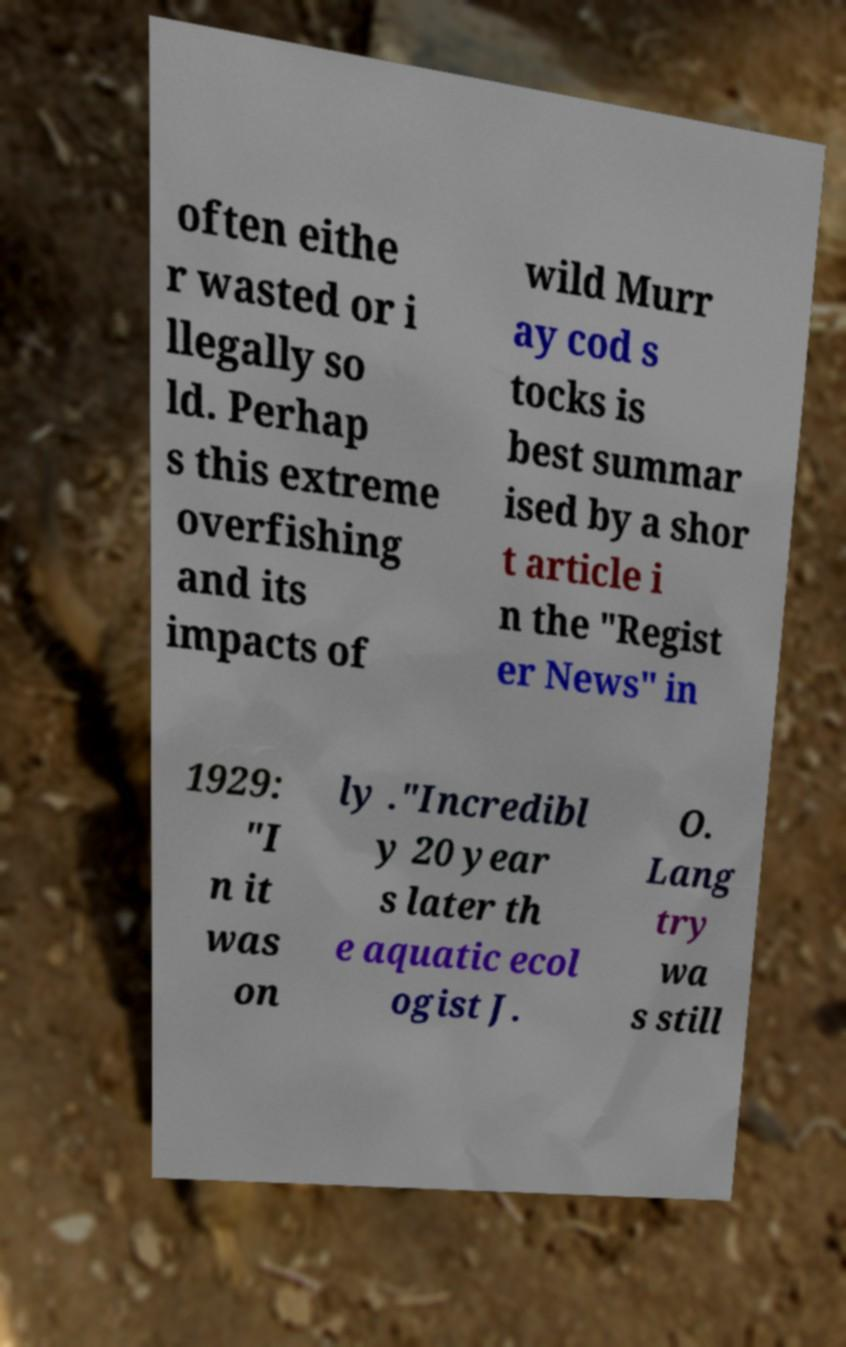Could you assist in decoding the text presented in this image and type it out clearly? often eithe r wasted or i llegally so ld. Perhap s this extreme overfishing and its impacts of wild Murr ay cod s tocks is best summar ised by a shor t article i n the "Regist er News" in 1929: "I n it was on ly ."Incredibl y 20 year s later th e aquatic ecol ogist J. O. Lang try wa s still 